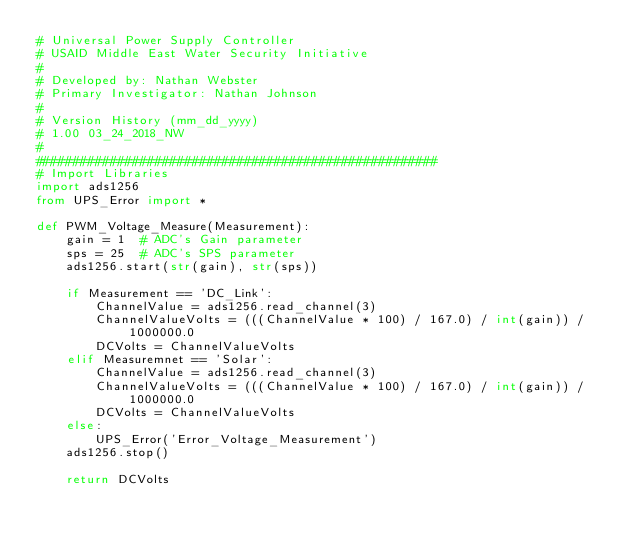<code> <loc_0><loc_0><loc_500><loc_500><_Python_># Universal Power Supply Controller
# USAID Middle East Water Security Initiative
#
# Developed by: Nathan Webster
# Primary Investigator: Nathan Johnson
#
# Version History (mm_dd_yyyy)
# 1.00 03_24_2018_NW
#
######################################################
# Import Libraries
import ads1256
from UPS_Error import *

def PWM_Voltage_Measure(Measurement):
    gain = 1  # ADC's Gain parameter
    sps = 25  # ADC's SPS parameter
    ads1256.start(str(gain), str(sps))

    if Measurement == 'DC_Link':
        ChannelValue = ads1256.read_channel(3)
        ChannelValueVolts = (((ChannelValue * 100) / 167.0) / int(gain)) / 1000000.0
        DCVolts = ChannelValueVolts
    elif Measuremnet == 'Solar':
        ChannelValue = ads1256.read_channel(3)
        ChannelValueVolts = (((ChannelValue * 100) / 167.0) / int(gain)) / 1000000.0
        DCVolts = ChannelValueVolts
    else:
        UPS_Error('Error_Voltage_Measurement')
    ads1256.stop()

    return DCVolts</code> 